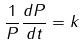Convert formula to latex. <formula><loc_0><loc_0><loc_500><loc_500>\frac { 1 } { P } \frac { d P } { d t } = k</formula> 